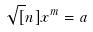<formula> <loc_0><loc_0><loc_500><loc_500>\sqrt { [ } n ] { x ^ { m } } = a</formula> 